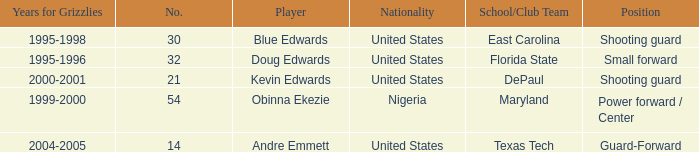What's the highest player number from the list from 2000-2001 21.0. 